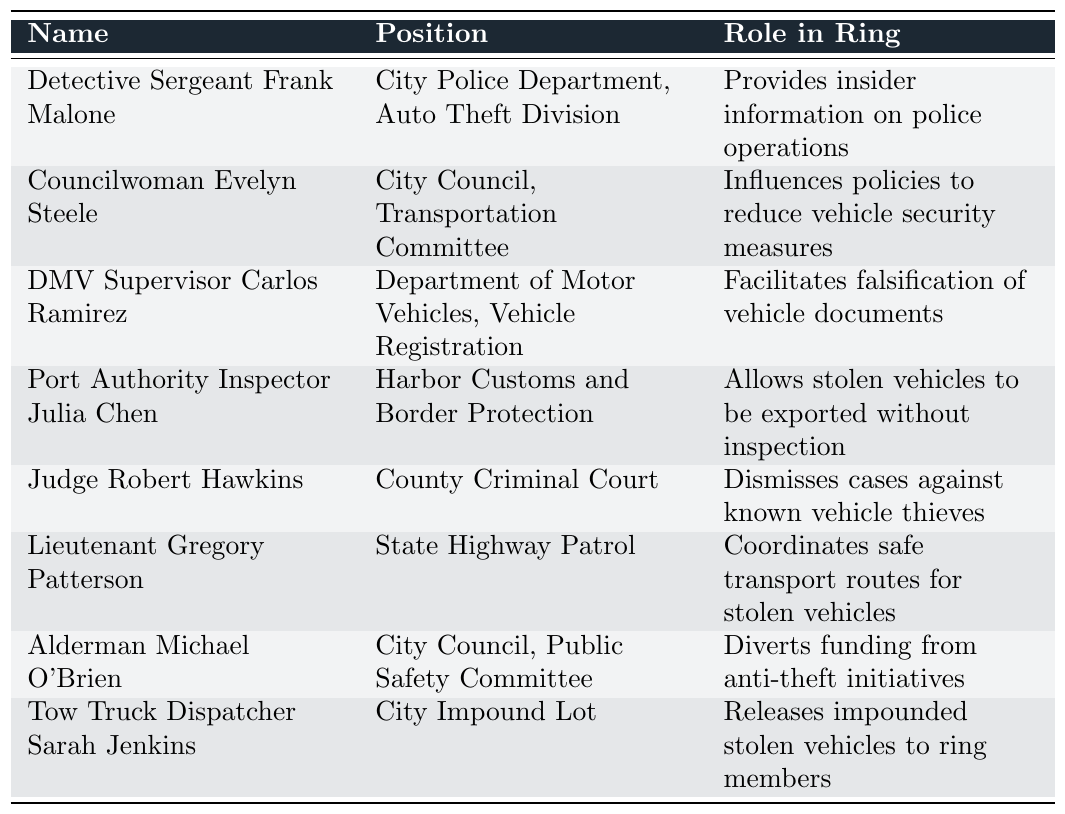What is the role of Detective Sergeant Frank Malone in the vehicle theft ring? According to the table, Detective Sergeant Frank Malone provides insider information on police operations, indicating his involvement in facilitating vehicle theft activities.
Answer: Provides insider information on police operations Who is responsible for influencing policies to reduce vehicle security measures? The table shows that Councilwoman Evelyn Steele is the one who influences policies to reduce vehicle security measures.
Answer: Councilwoman Evelyn Steele What position does the Tow Truck Dispatcher Sarah Jenkins hold? From the table, it is clear that Sarah Jenkins holds the position of Tow Truck Dispatcher at the City Impound Lot.
Answer: Tow Truck Dispatcher at the City Impound Lot How many officials are involved in the vehicle theft ring? There are a total of 8 officials listed in the table who are involved in the vehicle theft ring.
Answer: 8 Does Judge Robert Hawkins support vehicle thieves? Yes, the table indicates that Judge Robert Hawkins dismisses cases against known vehicle thieves, suggesting his support for them.
Answer: Yes Which official is involved in facilitating falsification of vehicle documents? The table states that DMV Supervisor Carlos Ramirez facilitates the falsification of vehicle documents, thus playing a significant role in the theft ring.
Answer: DMV Supervisor Carlos Ramirez How many positions belong to members of the City Council? There are 3 officials from the City Council listed in the table: Councilwoman Evelyn Steele, Alderman Michael O'Brien, and Tow Truck Dispatcher Sarah Jenkins. Hence, the total is 3.
Answer: 3 What is the relationship between Lieutenant Gregory Patterson and stolen vehicles? The table reveals that Lieutenant Gregory Patterson coordinates safe transport routes for stolen vehicles, indicating his active involvement in the theft scheme.
Answer: Coordinates safe transport routes for stolen vehicles Which official is involved in allowing stolen vehicles to be exported without inspection? Port Authority Inspector Julia Chen is the official responsible for allowing stolen vehicles to be exported without inspection, as mentioned in the table.
Answer: Port Authority Inspector Julia Chen Are there any officials associated with the Department of Motor Vehicles? Yes, DMV Supervisor Carlos Ramirez is associated with the Department of Motor Vehicles and is listed in the table.
Answer: Yes 